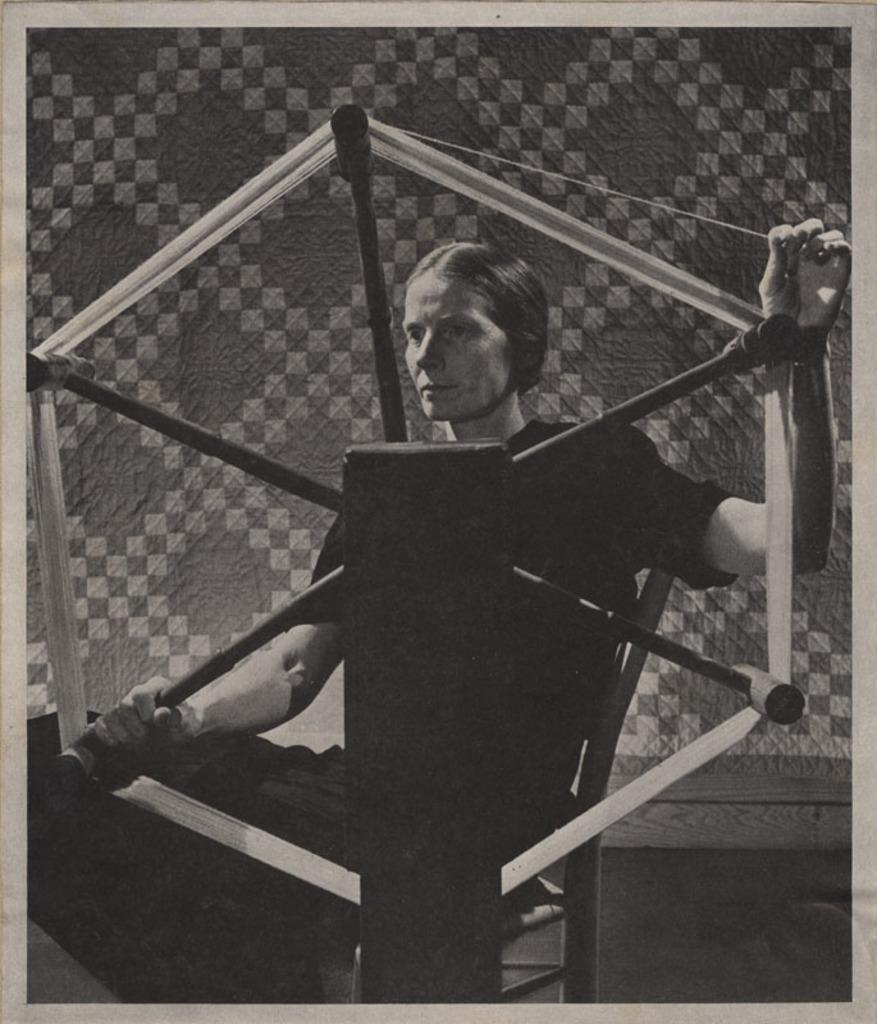How would you summarize this image in a sentence or two? In this picture we can see a woman holding a wheel with her hand and in the background we can see wall. 